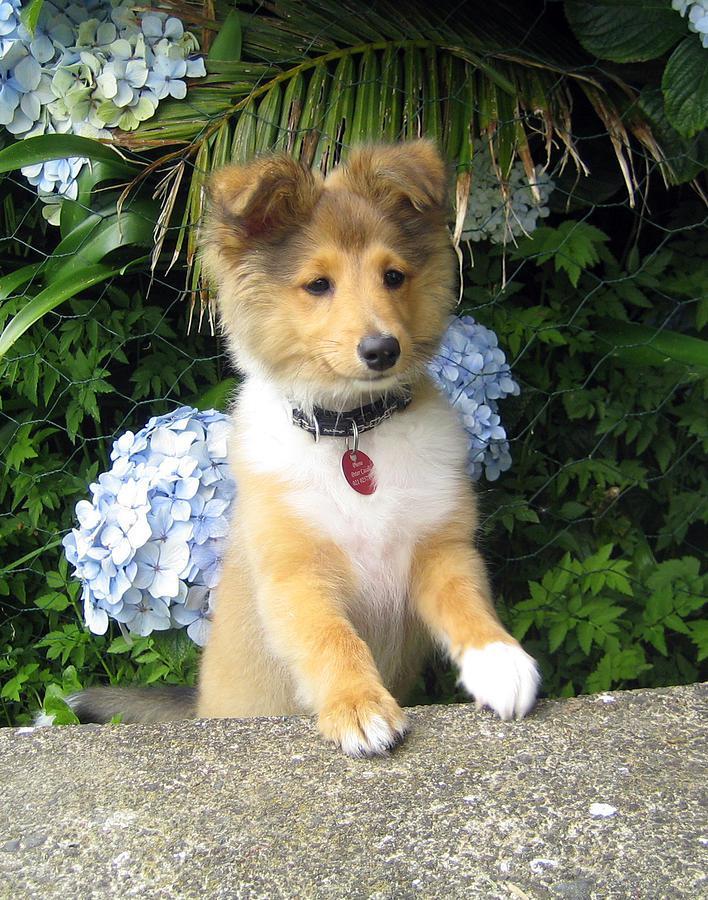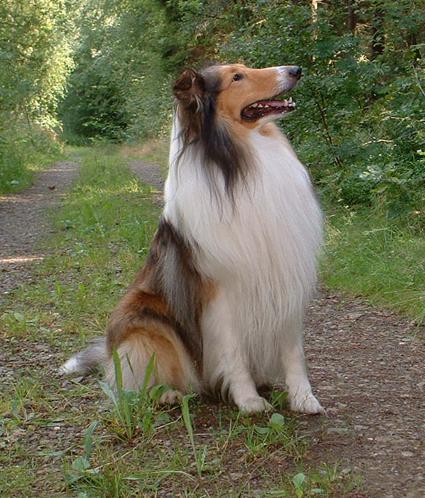The first image is the image on the left, the second image is the image on the right. For the images shown, is this caption "An adult collie dog poses in a scene with vibrant flowers." true? Answer yes or no. No. 